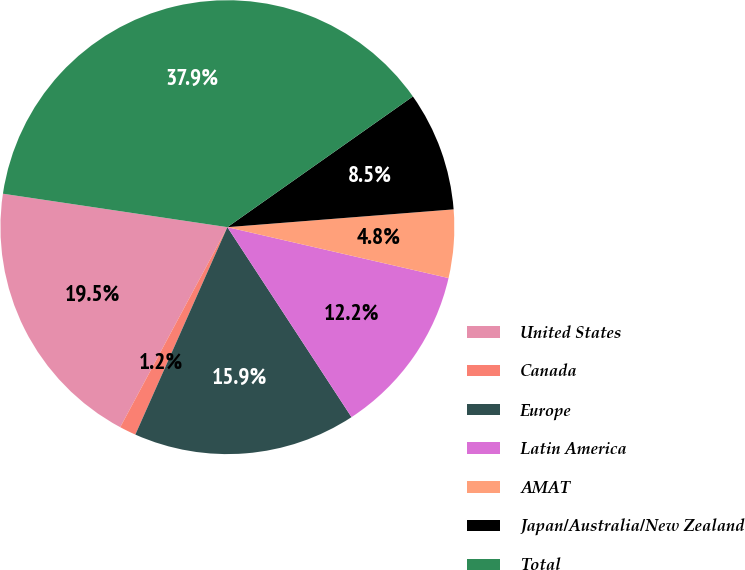Convert chart. <chart><loc_0><loc_0><loc_500><loc_500><pie_chart><fcel>United States<fcel>Canada<fcel>Europe<fcel>Latin America<fcel>AMAT<fcel>Japan/Australia/New Zealand<fcel>Total<nl><fcel>19.53%<fcel>1.18%<fcel>15.86%<fcel>12.19%<fcel>4.85%<fcel>8.52%<fcel>37.88%<nl></chart> 